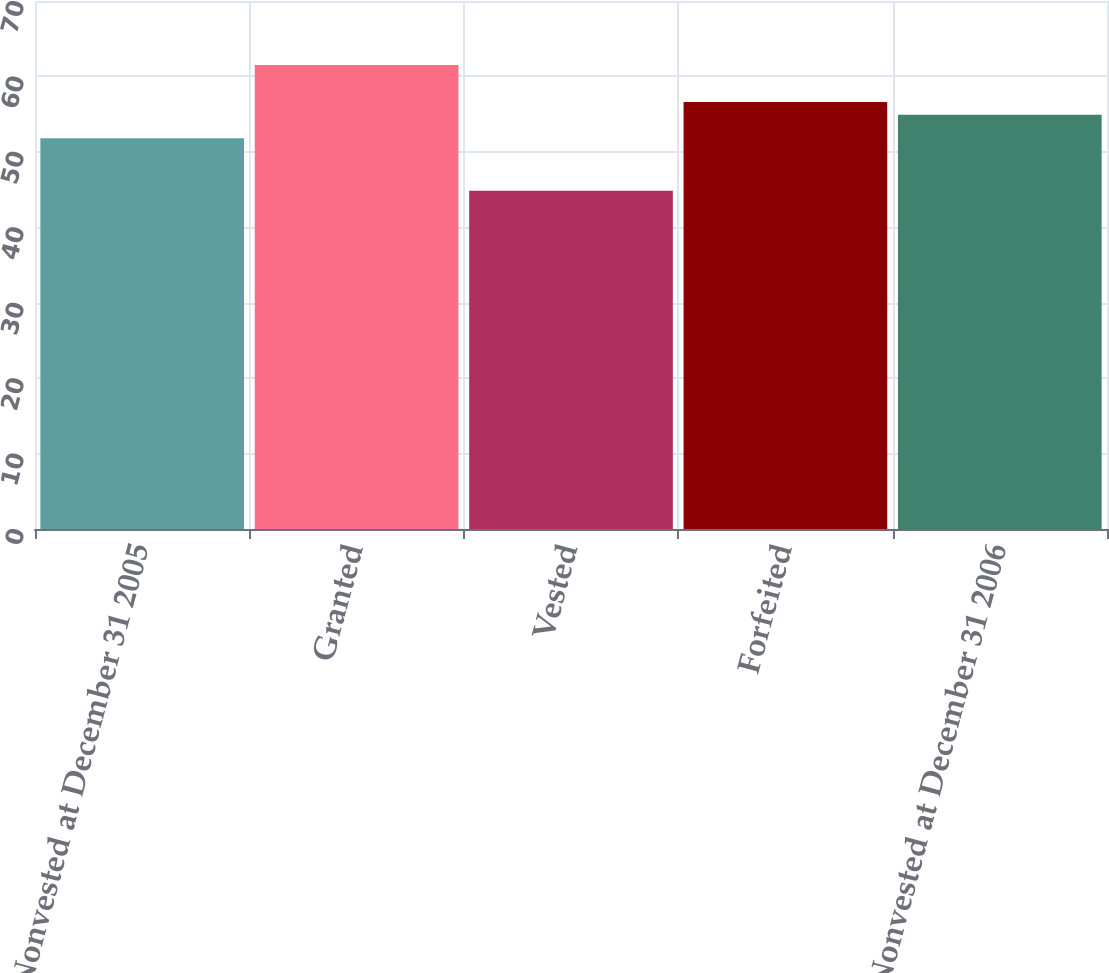<chart> <loc_0><loc_0><loc_500><loc_500><bar_chart><fcel>Nonvested at December 31 2005<fcel>Granted<fcel>Vested<fcel>Forfeited<fcel>Nonvested at December 31 2006<nl><fcel>51.8<fcel>61.52<fcel>44.84<fcel>56.6<fcel>54.93<nl></chart> 